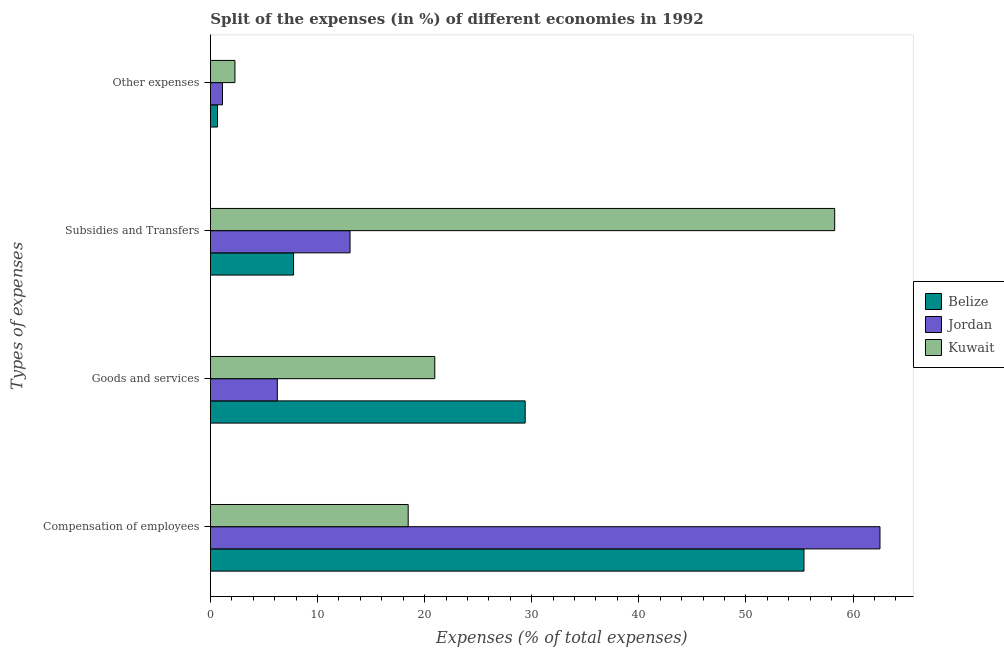How many groups of bars are there?
Offer a terse response. 4. Are the number of bars per tick equal to the number of legend labels?
Ensure brevity in your answer.  Yes. What is the label of the 3rd group of bars from the top?
Your response must be concise. Goods and services. What is the percentage of amount spent on goods and services in Kuwait?
Make the answer very short. 20.95. Across all countries, what is the maximum percentage of amount spent on compensation of employees?
Provide a short and direct response. 62.52. Across all countries, what is the minimum percentage of amount spent on subsidies?
Provide a succinct answer. 7.77. In which country was the percentage of amount spent on compensation of employees maximum?
Give a very brief answer. Jordan. In which country was the percentage of amount spent on other expenses minimum?
Offer a very short reply. Belize. What is the total percentage of amount spent on other expenses in the graph?
Keep it short and to the point. 4.08. What is the difference between the percentage of amount spent on compensation of employees in Kuwait and that in Jordan?
Give a very brief answer. -44.05. What is the difference between the percentage of amount spent on other expenses in Belize and the percentage of amount spent on compensation of employees in Jordan?
Offer a terse response. -61.85. What is the average percentage of amount spent on other expenses per country?
Provide a succinct answer. 1.36. What is the difference between the percentage of amount spent on goods and services and percentage of amount spent on compensation of employees in Jordan?
Your answer should be very brief. -56.27. In how many countries, is the percentage of amount spent on goods and services greater than 34 %?
Offer a very short reply. 0. What is the ratio of the percentage of amount spent on other expenses in Belize to that in Kuwait?
Offer a very short reply. 0.29. What is the difference between the highest and the second highest percentage of amount spent on other expenses?
Make the answer very short. 1.17. What is the difference between the highest and the lowest percentage of amount spent on other expenses?
Provide a succinct answer. 1.63. What does the 3rd bar from the top in Goods and services represents?
Your response must be concise. Belize. What does the 2nd bar from the bottom in Compensation of employees represents?
Give a very brief answer. Jordan. What is the difference between two consecutive major ticks on the X-axis?
Your answer should be very brief. 10. Are the values on the major ticks of X-axis written in scientific E-notation?
Give a very brief answer. No. Does the graph contain grids?
Give a very brief answer. No. Where does the legend appear in the graph?
Keep it short and to the point. Center right. What is the title of the graph?
Offer a terse response. Split of the expenses (in %) of different economies in 1992. What is the label or title of the X-axis?
Offer a terse response. Expenses (% of total expenses). What is the label or title of the Y-axis?
Provide a short and direct response. Types of expenses. What is the Expenses (% of total expenses) in Belize in Compensation of employees?
Keep it short and to the point. 55.42. What is the Expenses (% of total expenses) of Jordan in Compensation of employees?
Provide a succinct answer. 62.52. What is the Expenses (% of total expenses) in Kuwait in Compensation of employees?
Offer a very short reply. 18.47. What is the Expenses (% of total expenses) in Belize in Goods and services?
Provide a succinct answer. 29.39. What is the Expenses (% of total expenses) in Jordan in Goods and services?
Your response must be concise. 6.25. What is the Expenses (% of total expenses) in Kuwait in Goods and services?
Provide a succinct answer. 20.95. What is the Expenses (% of total expenses) of Belize in Subsidies and Transfers?
Your response must be concise. 7.77. What is the Expenses (% of total expenses) of Jordan in Subsidies and Transfers?
Keep it short and to the point. 13.04. What is the Expenses (% of total expenses) in Kuwait in Subsidies and Transfers?
Offer a very short reply. 58.29. What is the Expenses (% of total expenses) in Belize in Other expenses?
Offer a very short reply. 0.66. What is the Expenses (% of total expenses) in Jordan in Other expenses?
Your answer should be very brief. 1.13. What is the Expenses (% of total expenses) in Kuwait in Other expenses?
Keep it short and to the point. 2.29. Across all Types of expenses, what is the maximum Expenses (% of total expenses) in Belize?
Offer a terse response. 55.42. Across all Types of expenses, what is the maximum Expenses (% of total expenses) in Jordan?
Provide a short and direct response. 62.52. Across all Types of expenses, what is the maximum Expenses (% of total expenses) of Kuwait?
Your response must be concise. 58.29. Across all Types of expenses, what is the minimum Expenses (% of total expenses) of Belize?
Offer a very short reply. 0.66. Across all Types of expenses, what is the minimum Expenses (% of total expenses) in Jordan?
Your response must be concise. 1.13. Across all Types of expenses, what is the minimum Expenses (% of total expenses) of Kuwait?
Your response must be concise. 2.29. What is the total Expenses (% of total expenses) of Belize in the graph?
Ensure brevity in your answer.  93.24. What is the total Expenses (% of total expenses) in Jordan in the graph?
Give a very brief answer. 82.93. What is the total Expenses (% of total expenses) in Kuwait in the graph?
Your answer should be compact. 100. What is the difference between the Expenses (% of total expenses) in Belize in Compensation of employees and that in Goods and services?
Your response must be concise. 26.03. What is the difference between the Expenses (% of total expenses) in Jordan in Compensation of employees and that in Goods and services?
Offer a terse response. 56.27. What is the difference between the Expenses (% of total expenses) of Kuwait in Compensation of employees and that in Goods and services?
Offer a terse response. -2.48. What is the difference between the Expenses (% of total expenses) in Belize in Compensation of employees and that in Subsidies and Transfers?
Ensure brevity in your answer.  47.65. What is the difference between the Expenses (% of total expenses) in Jordan in Compensation of employees and that in Subsidies and Transfers?
Offer a very short reply. 49.48. What is the difference between the Expenses (% of total expenses) in Kuwait in Compensation of employees and that in Subsidies and Transfers?
Your response must be concise. -39.82. What is the difference between the Expenses (% of total expenses) in Belize in Compensation of employees and that in Other expenses?
Provide a short and direct response. 54.76. What is the difference between the Expenses (% of total expenses) in Jordan in Compensation of employees and that in Other expenses?
Provide a short and direct response. 61.39. What is the difference between the Expenses (% of total expenses) of Kuwait in Compensation of employees and that in Other expenses?
Your answer should be compact. 16.17. What is the difference between the Expenses (% of total expenses) of Belize in Goods and services and that in Subsidies and Transfers?
Your response must be concise. 21.62. What is the difference between the Expenses (% of total expenses) in Jordan in Goods and services and that in Subsidies and Transfers?
Ensure brevity in your answer.  -6.79. What is the difference between the Expenses (% of total expenses) of Kuwait in Goods and services and that in Subsidies and Transfers?
Your answer should be very brief. -37.34. What is the difference between the Expenses (% of total expenses) in Belize in Goods and services and that in Other expenses?
Your response must be concise. 28.73. What is the difference between the Expenses (% of total expenses) of Jordan in Goods and services and that in Other expenses?
Your answer should be very brief. 5.12. What is the difference between the Expenses (% of total expenses) of Kuwait in Goods and services and that in Other expenses?
Offer a terse response. 18.66. What is the difference between the Expenses (% of total expenses) in Belize in Subsidies and Transfers and that in Other expenses?
Keep it short and to the point. 7.1. What is the difference between the Expenses (% of total expenses) of Jordan in Subsidies and Transfers and that in Other expenses?
Your response must be concise. 11.91. What is the difference between the Expenses (% of total expenses) of Kuwait in Subsidies and Transfers and that in Other expenses?
Your answer should be very brief. 56. What is the difference between the Expenses (% of total expenses) of Belize in Compensation of employees and the Expenses (% of total expenses) of Jordan in Goods and services?
Your answer should be very brief. 49.17. What is the difference between the Expenses (% of total expenses) of Belize in Compensation of employees and the Expenses (% of total expenses) of Kuwait in Goods and services?
Give a very brief answer. 34.47. What is the difference between the Expenses (% of total expenses) of Jordan in Compensation of employees and the Expenses (% of total expenses) of Kuwait in Goods and services?
Your response must be concise. 41.57. What is the difference between the Expenses (% of total expenses) in Belize in Compensation of employees and the Expenses (% of total expenses) in Jordan in Subsidies and Transfers?
Provide a succinct answer. 42.38. What is the difference between the Expenses (% of total expenses) in Belize in Compensation of employees and the Expenses (% of total expenses) in Kuwait in Subsidies and Transfers?
Keep it short and to the point. -2.87. What is the difference between the Expenses (% of total expenses) in Jordan in Compensation of employees and the Expenses (% of total expenses) in Kuwait in Subsidies and Transfers?
Give a very brief answer. 4.23. What is the difference between the Expenses (% of total expenses) of Belize in Compensation of employees and the Expenses (% of total expenses) of Jordan in Other expenses?
Provide a short and direct response. 54.3. What is the difference between the Expenses (% of total expenses) of Belize in Compensation of employees and the Expenses (% of total expenses) of Kuwait in Other expenses?
Your answer should be very brief. 53.13. What is the difference between the Expenses (% of total expenses) of Jordan in Compensation of employees and the Expenses (% of total expenses) of Kuwait in Other expenses?
Keep it short and to the point. 60.23. What is the difference between the Expenses (% of total expenses) in Belize in Goods and services and the Expenses (% of total expenses) in Jordan in Subsidies and Transfers?
Provide a short and direct response. 16.35. What is the difference between the Expenses (% of total expenses) in Belize in Goods and services and the Expenses (% of total expenses) in Kuwait in Subsidies and Transfers?
Offer a very short reply. -28.9. What is the difference between the Expenses (% of total expenses) in Jordan in Goods and services and the Expenses (% of total expenses) in Kuwait in Subsidies and Transfers?
Make the answer very short. -52.04. What is the difference between the Expenses (% of total expenses) of Belize in Goods and services and the Expenses (% of total expenses) of Jordan in Other expenses?
Your answer should be very brief. 28.26. What is the difference between the Expenses (% of total expenses) in Belize in Goods and services and the Expenses (% of total expenses) in Kuwait in Other expenses?
Offer a very short reply. 27.1. What is the difference between the Expenses (% of total expenses) in Jordan in Goods and services and the Expenses (% of total expenses) in Kuwait in Other expenses?
Your answer should be very brief. 3.96. What is the difference between the Expenses (% of total expenses) of Belize in Subsidies and Transfers and the Expenses (% of total expenses) of Jordan in Other expenses?
Your answer should be very brief. 6.64. What is the difference between the Expenses (% of total expenses) of Belize in Subsidies and Transfers and the Expenses (% of total expenses) of Kuwait in Other expenses?
Your response must be concise. 5.48. What is the difference between the Expenses (% of total expenses) of Jordan in Subsidies and Transfers and the Expenses (% of total expenses) of Kuwait in Other expenses?
Offer a very short reply. 10.75. What is the average Expenses (% of total expenses) in Belize per Types of expenses?
Your answer should be very brief. 23.31. What is the average Expenses (% of total expenses) in Jordan per Types of expenses?
Ensure brevity in your answer.  20.73. What is the difference between the Expenses (% of total expenses) in Belize and Expenses (% of total expenses) in Jordan in Compensation of employees?
Your answer should be compact. -7.1. What is the difference between the Expenses (% of total expenses) in Belize and Expenses (% of total expenses) in Kuwait in Compensation of employees?
Your answer should be compact. 36.95. What is the difference between the Expenses (% of total expenses) of Jordan and Expenses (% of total expenses) of Kuwait in Compensation of employees?
Provide a short and direct response. 44.05. What is the difference between the Expenses (% of total expenses) of Belize and Expenses (% of total expenses) of Jordan in Goods and services?
Ensure brevity in your answer.  23.14. What is the difference between the Expenses (% of total expenses) of Belize and Expenses (% of total expenses) of Kuwait in Goods and services?
Your answer should be compact. 8.44. What is the difference between the Expenses (% of total expenses) in Jordan and Expenses (% of total expenses) in Kuwait in Goods and services?
Make the answer very short. -14.7. What is the difference between the Expenses (% of total expenses) of Belize and Expenses (% of total expenses) of Jordan in Subsidies and Transfers?
Your answer should be very brief. -5.27. What is the difference between the Expenses (% of total expenses) in Belize and Expenses (% of total expenses) in Kuwait in Subsidies and Transfers?
Provide a succinct answer. -50.52. What is the difference between the Expenses (% of total expenses) of Jordan and Expenses (% of total expenses) of Kuwait in Subsidies and Transfers?
Offer a terse response. -45.25. What is the difference between the Expenses (% of total expenses) in Belize and Expenses (% of total expenses) in Jordan in Other expenses?
Ensure brevity in your answer.  -0.46. What is the difference between the Expenses (% of total expenses) of Belize and Expenses (% of total expenses) of Kuwait in Other expenses?
Your answer should be compact. -1.63. What is the difference between the Expenses (% of total expenses) in Jordan and Expenses (% of total expenses) in Kuwait in Other expenses?
Give a very brief answer. -1.17. What is the ratio of the Expenses (% of total expenses) of Belize in Compensation of employees to that in Goods and services?
Provide a succinct answer. 1.89. What is the ratio of the Expenses (% of total expenses) in Jordan in Compensation of employees to that in Goods and services?
Offer a very short reply. 10. What is the ratio of the Expenses (% of total expenses) in Kuwait in Compensation of employees to that in Goods and services?
Your response must be concise. 0.88. What is the ratio of the Expenses (% of total expenses) in Belize in Compensation of employees to that in Subsidies and Transfers?
Keep it short and to the point. 7.13. What is the ratio of the Expenses (% of total expenses) of Jordan in Compensation of employees to that in Subsidies and Transfers?
Keep it short and to the point. 4.79. What is the ratio of the Expenses (% of total expenses) in Kuwait in Compensation of employees to that in Subsidies and Transfers?
Your answer should be compact. 0.32. What is the ratio of the Expenses (% of total expenses) in Belize in Compensation of employees to that in Other expenses?
Your answer should be compact. 83.49. What is the ratio of the Expenses (% of total expenses) in Jordan in Compensation of employees to that in Other expenses?
Keep it short and to the point. 55.5. What is the ratio of the Expenses (% of total expenses) in Kuwait in Compensation of employees to that in Other expenses?
Make the answer very short. 8.06. What is the ratio of the Expenses (% of total expenses) in Belize in Goods and services to that in Subsidies and Transfers?
Offer a very short reply. 3.78. What is the ratio of the Expenses (% of total expenses) in Jordan in Goods and services to that in Subsidies and Transfers?
Offer a very short reply. 0.48. What is the ratio of the Expenses (% of total expenses) of Kuwait in Goods and services to that in Subsidies and Transfers?
Keep it short and to the point. 0.36. What is the ratio of the Expenses (% of total expenses) in Belize in Goods and services to that in Other expenses?
Your answer should be compact. 44.28. What is the ratio of the Expenses (% of total expenses) of Jordan in Goods and services to that in Other expenses?
Your response must be concise. 5.55. What is the ratio of the Expenses (% of total expenses) of Kuwait in Goods and services to that in Other expenses?
Make the answer very short. 9.14. What is the ratio of the Expenses (% of total expenses) of Belize in Subsidies and Transfers to that in Other expenses?
Provide a short and direct response. 11.7. What is the ratio of the Expenses (% of total expenses) in Jordan in Subsidies and Transfers to that in Other expenses?
Your answer should be very brief. 11.58. What is the ratio of the Expenses (% of total expenses) in Kuwait in Subsidies and Transfers to that in Other expenses?
Your answer should be very brief. 25.43. What is the difference between the highest and the second highest Expenses (% of total expenses) of Belize?
Ensure brevity in your answer.  26.03. What is the difference between the highest and the second highest Expenses (% of total expenses) of Jordan?
Offer a terse response. 49.48. What is the difference between the highest and the second highest Expenses (% of total expenses) of Kuwait?
Your response must be concise. 37.34. What is the difference between the highest and the lowest Expenses (% of total expenses) in Belize?
Offer a very short reply. 54.76. What is the difference between the highest and the lowest Expenses (% of total expenses) in Jordan?
Offer a terse response. 61.39. What is the difference between the highest and the lowest Expenses (% of total expenses) of Kuwait?
Make the answer very short. 56. 